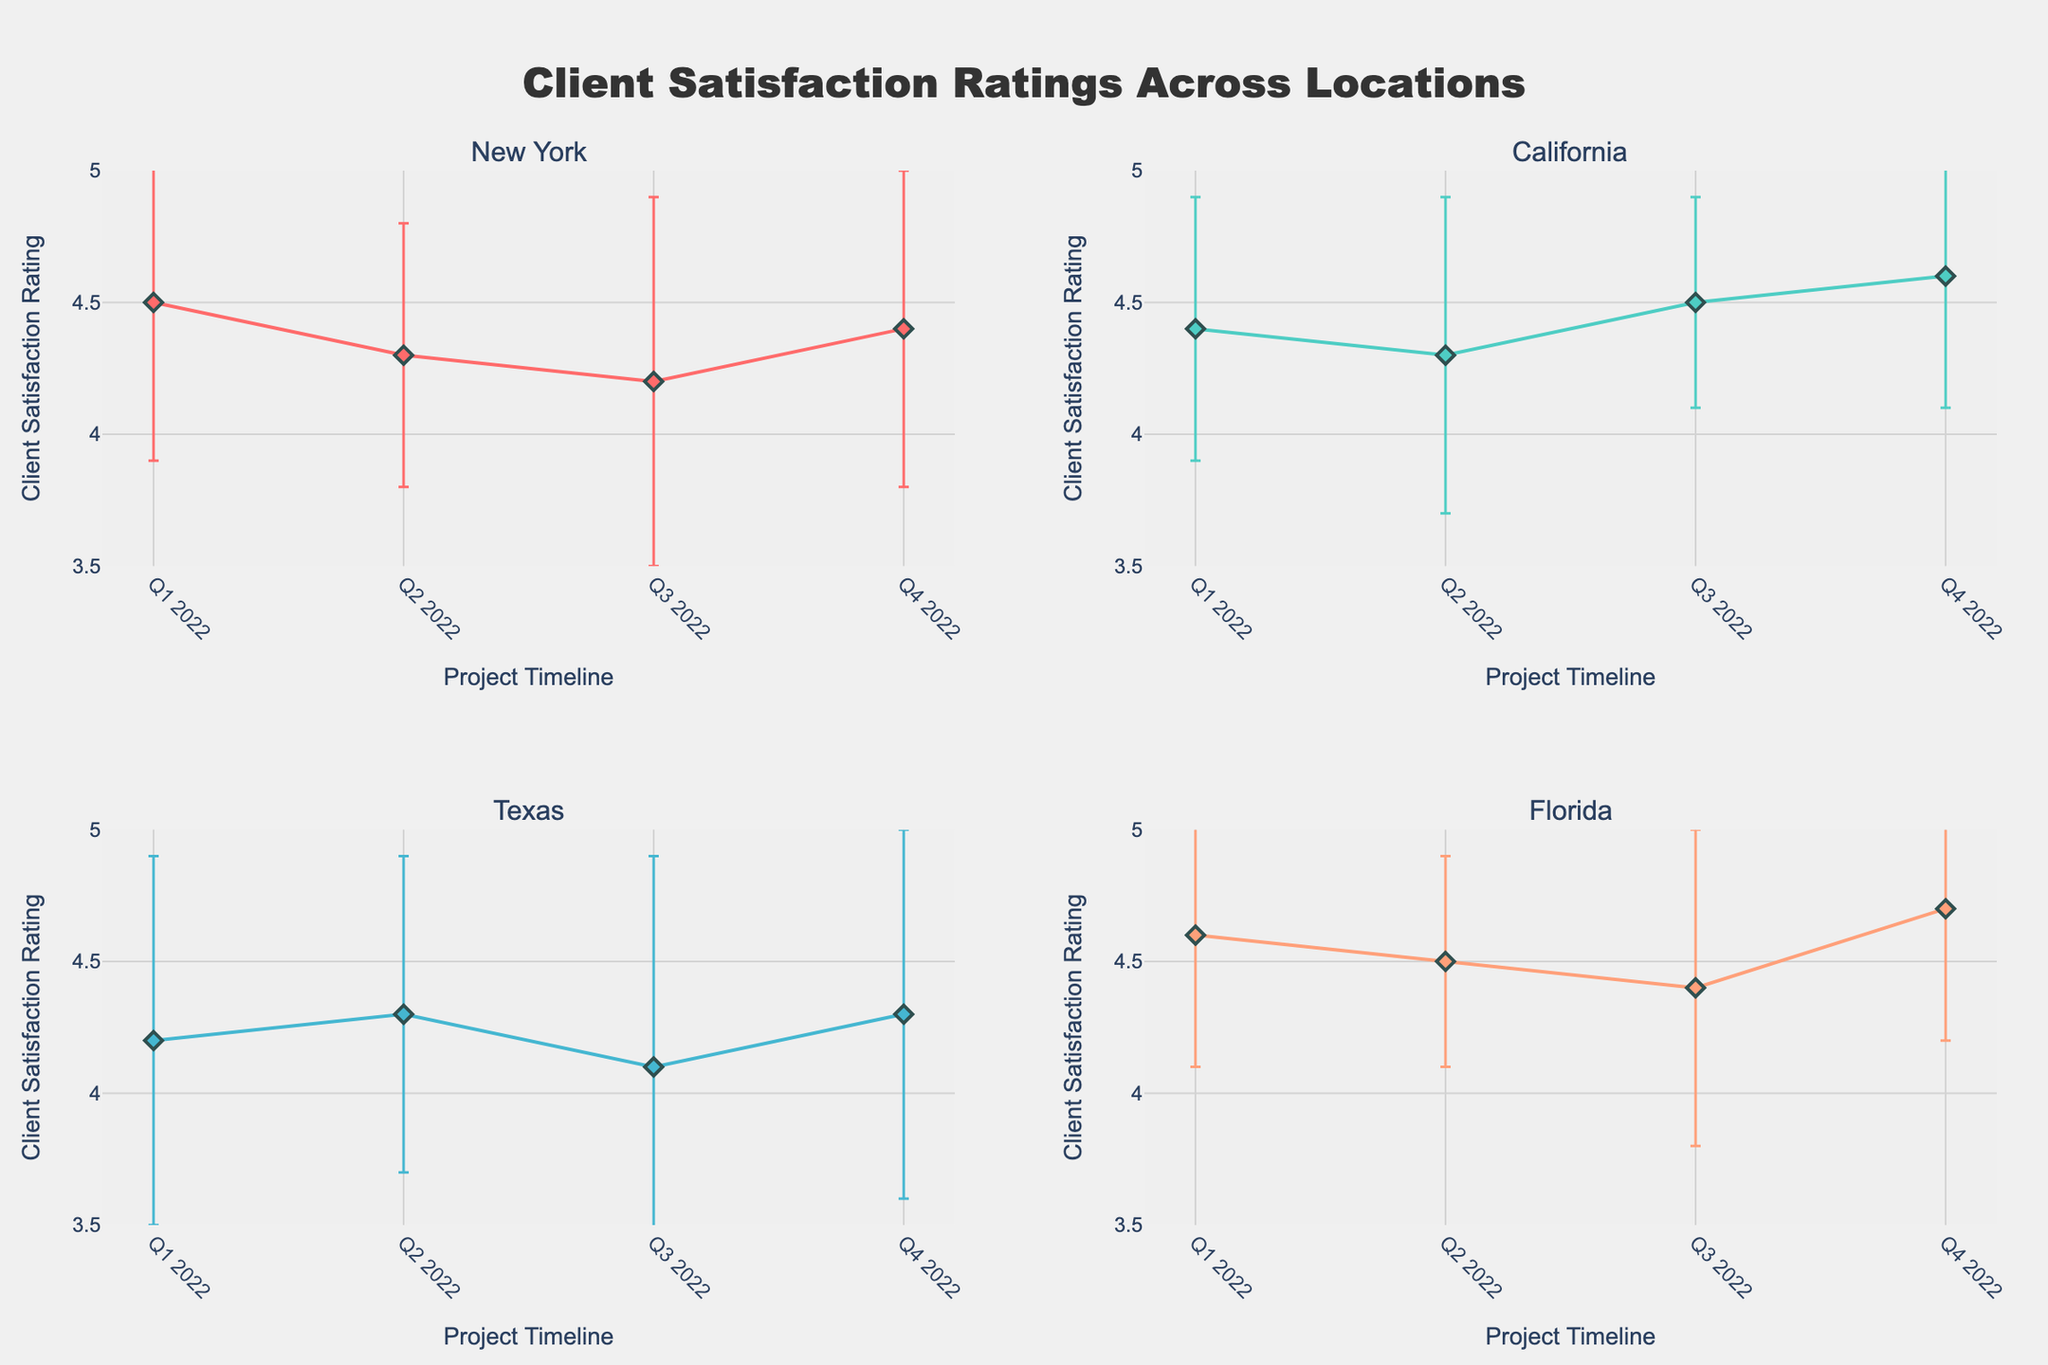what is the title of the plot? The title of the plot is usually at the top and represents the overall subject of the figure. Here, it says "Client Satisfaction Ratings Across Locations".
Answer: Client Satisfaction Ratings Across Locations Which geographical location has the highest average client satisfaction rating in Q4 2022? To find this, look at the Q4 2022 data point in each of the four subplots and compare their satisfaction ratings. Florida has the highest rating at 4.7.
Answer: Florida What is the average client satisfaction rating in New York across all project timelines? To find the average, sum the client satisfaction ratings in New York for Q1, Q2, Q3, and Q4, and then divide by 4. The ratings are 4.5, 4.3, 4.2, and 4.4, respectively. So, the average is (4.5 + 4.3 + 4.2 + 4.4) / 4 = 4.35.
Answer: 4.35 What is the total variation in client satisfaction ratings in Texas throughout 2022? Total variation can be found by summing the standard deviations for Texas across all quarters: 0.7, 0.6, 0.8, and 0.7. The total variation is 0.7 + 0.6 + 0.8 + 0.7 = 2.8.
Answer: 2.8 Which quarter shows the highest variability in client satisfaction ratings for California? The quarter with the highest variability has the highest standard deviation. For California, the standard deviations are 0.5, 0.6, 0.4, and 0.5 for Q1, Q2, Q3, and Q4, respectively. Q2 has the highest variability at 0.6.
Answer: Q2 How does the trend in client satisfaction ratings for Florida compare to California? Compare the trends, which means looking at how ratings change over time for both locations. Florida shows a mostly increasing trend from 4.6 to 4.7, while California also shows an increasing trend but started lower at 4.4 and ended up at 4.6.
Answer: Both show increasing trends, but Florida starts and remains higher Among New York, California, Texas, and Florida, which location has the least variation in client satisfaction rating in Q2 2022? Compare the standard deviations in Q2 2022 for all locations. New York has 0.5, California has 0.6, Texas has 0.6, and Florida has 0.4. Florida has the least variation with a standard deviation of 0.4.
Answer: Florida What is the difference in the client satisfaction rating between Q3 and Q4 2022 for Texas? Subtract the Q3 rating from the Q4 rating for Texas. In Q3, the rating is 4.1 and in Q4, it's 4.3. The difference is 4.3 - 4.1 = 0.2.
Answer: 0.2 Which quarter has the lowest client satisfaction rating across all locations? Identify the lowest rating in each subplot and compare them. The lowest rating is 4.1 in Q3 2022 for Texas.
Answer: Q3 2022 